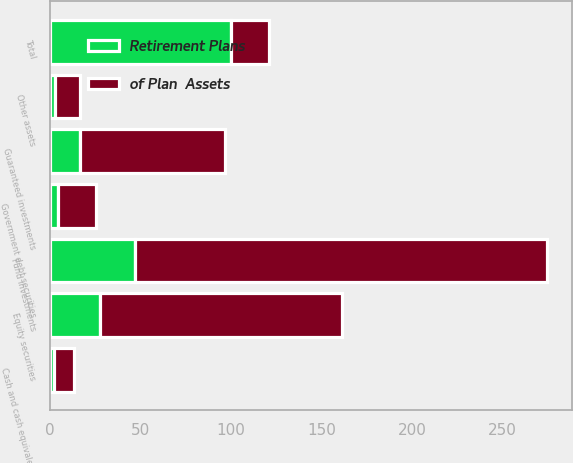Convert chart. <chart><loc_0><loc_0><loc_500><loc_500><stacked_bar_chart><ecel><fcel>Cash and cash equivalents<fcel>Fund investments<fcel>Equity securities<fcel>Government debt securities<fcel>Other assets<fcel>Guaranteed investments<fcel>Total<nl><fcel>of Plan  Assets<fcel>10.7<fcel>227.9<fcel>133.9<fcel>20.9<fcel>13.4<fcel>80.1<fcel>20.9<nl><fcel>Retirement Plans<fcel>2.2<fcel>46.8<fcel>27.5<fcel>4.3<fcel>2.8<fcel>16.5<fcel>100<nl></chart> 